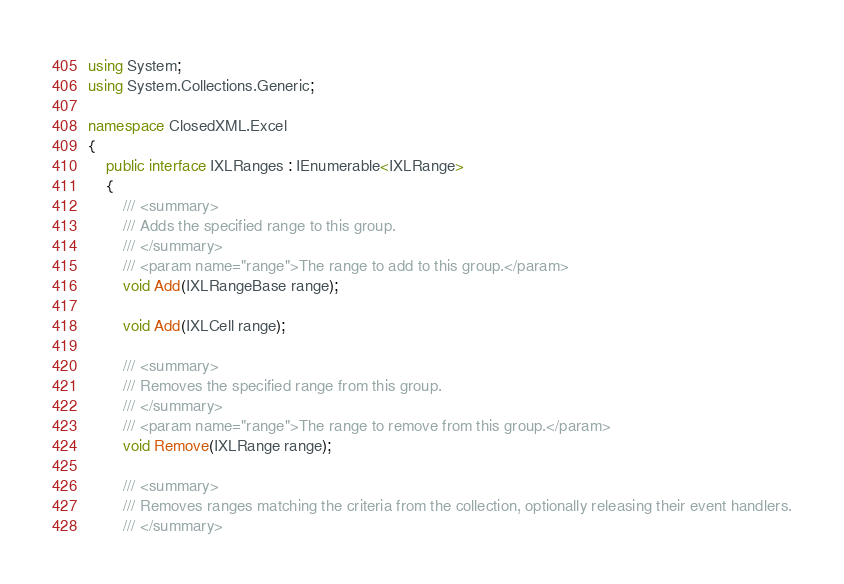<code> <loc_0><loc_0><loc_500><loc_500><_C#_>using System;
using System.Collections.Generic;

namespace ClosedXML.Excel
{
    public interface IXLRanges : IEnumerable<IXLRange>
    {
        /// <summary>
        /// Adds the specified range to this group.
        /// </summary>
        /// <param name="range">The range to add to this group.</param>
        void Add(IXLRangeBase range);

        void Add(IXLCell range);

        /// <summary>
        /// Removes the specified range from this group.
        /// </summary>
        /// <param name="range">The range to remove from this group.</param>
        void Remove(IXLRange range);

        /// <summary>
        /// Removes ranges matching the criteria from the collection, optionally releasing their event handlers.
        /// </summary></code> 